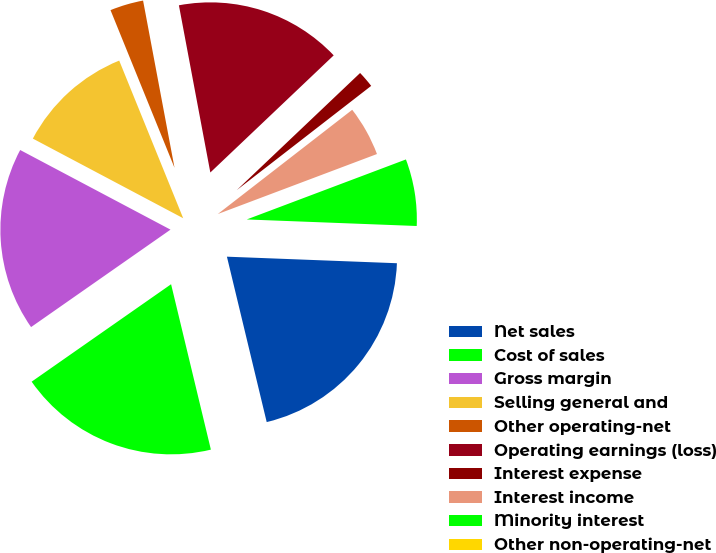Convert chart to OTSL. <chart><loc_0><loc_0><loc_500><loc_500><pie_chart><fcel>Net sales<fcel>Cost of sales<fcel>Gross margin<fcel>Selling general and<fcel>Other operating-net<fcel>Operating earnings (loss)<fcel>Interest expense<fcel>Interest income<fcel>Minority interest<fcel>Other non-operating-net<nl><fcel>20.63%<fcel>19.05%<fcel>17.46%<fcel>11.11%<fcel>3.18%<fcel>15.87%<fcel>1.59%<fcel>4.76%<fcel>6.35%<fcel>0.0%<nl></chart> 